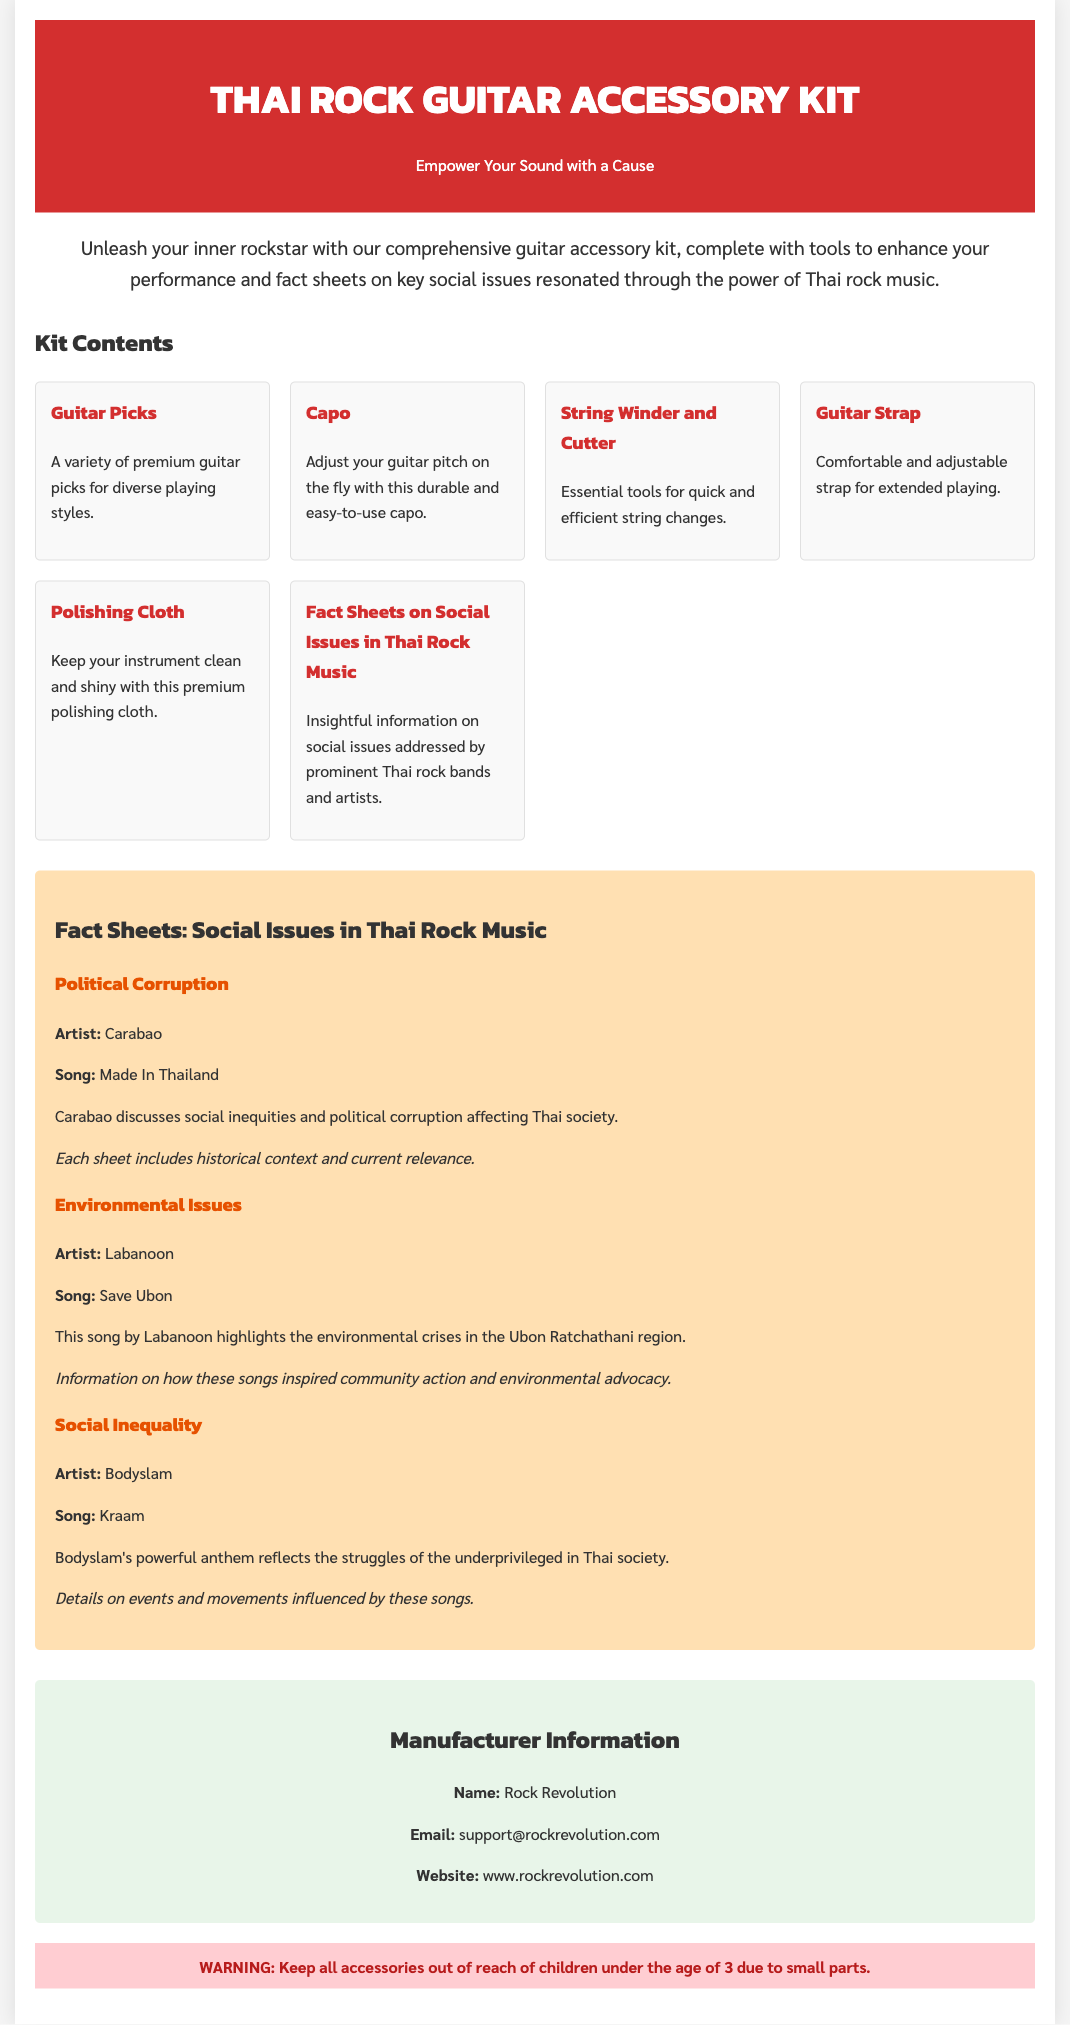What is the name of the product? The product is referred to as the "Thai Rock Guitar Accessory Kit" in the document.
Answer: Thai Rock Guitar Accessory Kit Who is the manufacturer? The document provides the name of the manufacturer as "Rock Revolution."
Answer: Rock Revolution What is included in the guitar accessory kit? The kit contents include items like Guitar Picks, Capo, and a Fact Sheet.
Answer: Guitar Picks, Capo, Fact Sheet Which artist discusses social inequities in their song according to the fact sheets? The fact sheet indicates that Carabao is the artist who discusses social inequities.
Answer: Carabao What social issue does Labanoon's song address? Labanoon's song "Save Ubon" addresses Environmental Issues based on the fact sheets.
Answer: Environmental Issues How many fact sheets are included in the document? The document lists three fact sheets on social issues in Thai rock music.
Answer: Three What is the email address for manufacturer support? The document specifies the support email as "support@rockrevolution.com."
Answer: support@rockrevolution.com What is the warning provided about the product? The warning states to keep all accessories out of reach of children under the age of 3 due to small parts.
Answer: Keep all accessories out of reach of children under the age of 3 What is the main theme of Bodyslam's song "Kraam"? The fact sheet notes that Bodyslam's song reflects the struggles of the underprivileged in Thai society.
Answer: Social Inequality 